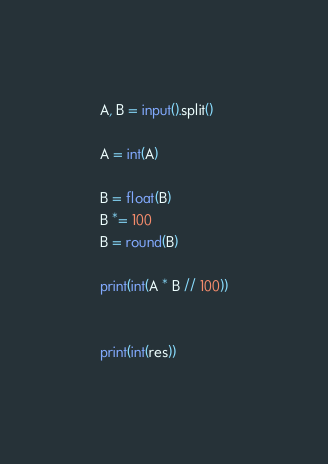Convert code to text. <code><loc_0><loc_0><loc_500><loc_500><_Python_>A, B = input().split()

A = int(A)

B = float(B)
B *= 100
B = round(B)

print(int(A * B // 100))


print(int(res))

</code> 